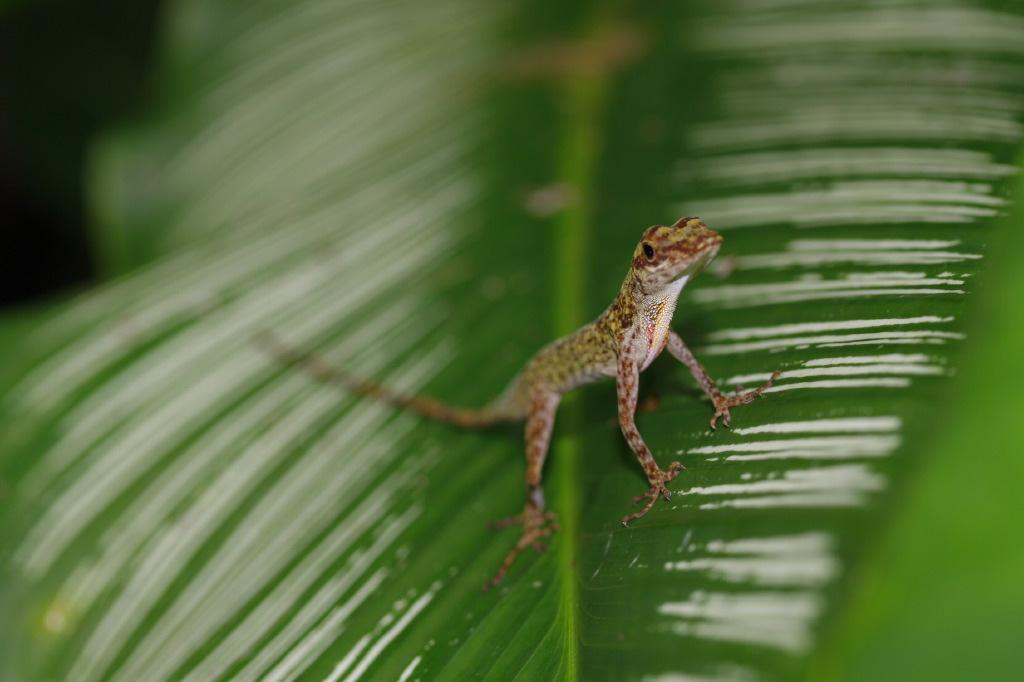What type of animal is in the image? There is a brown-colored lizard in the image. Where is the lizard located in the image? The lizard is sitting on a green leaf. What is the condition of the leaf in the image? The leaf appears to be wet. What language is the lizard learning in the image? The image does not depict the lizard learning any language, as lizards do not have the ability to learn languages. 